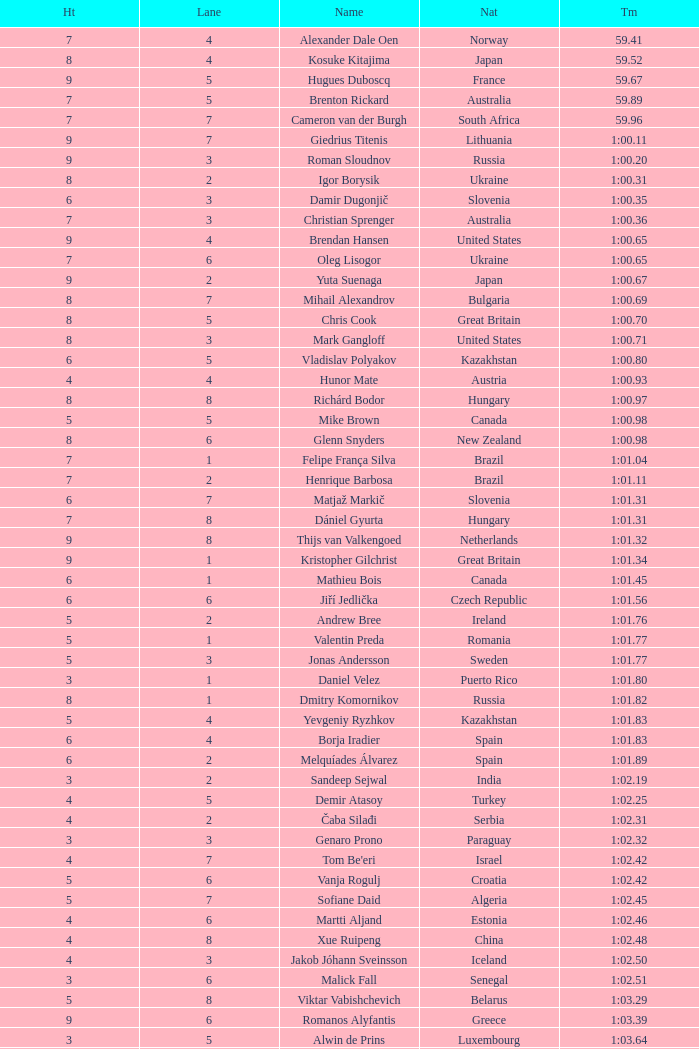What is the time in a heat smaller than 5, in Lane 5, for Vietnam? 1:06.36. 